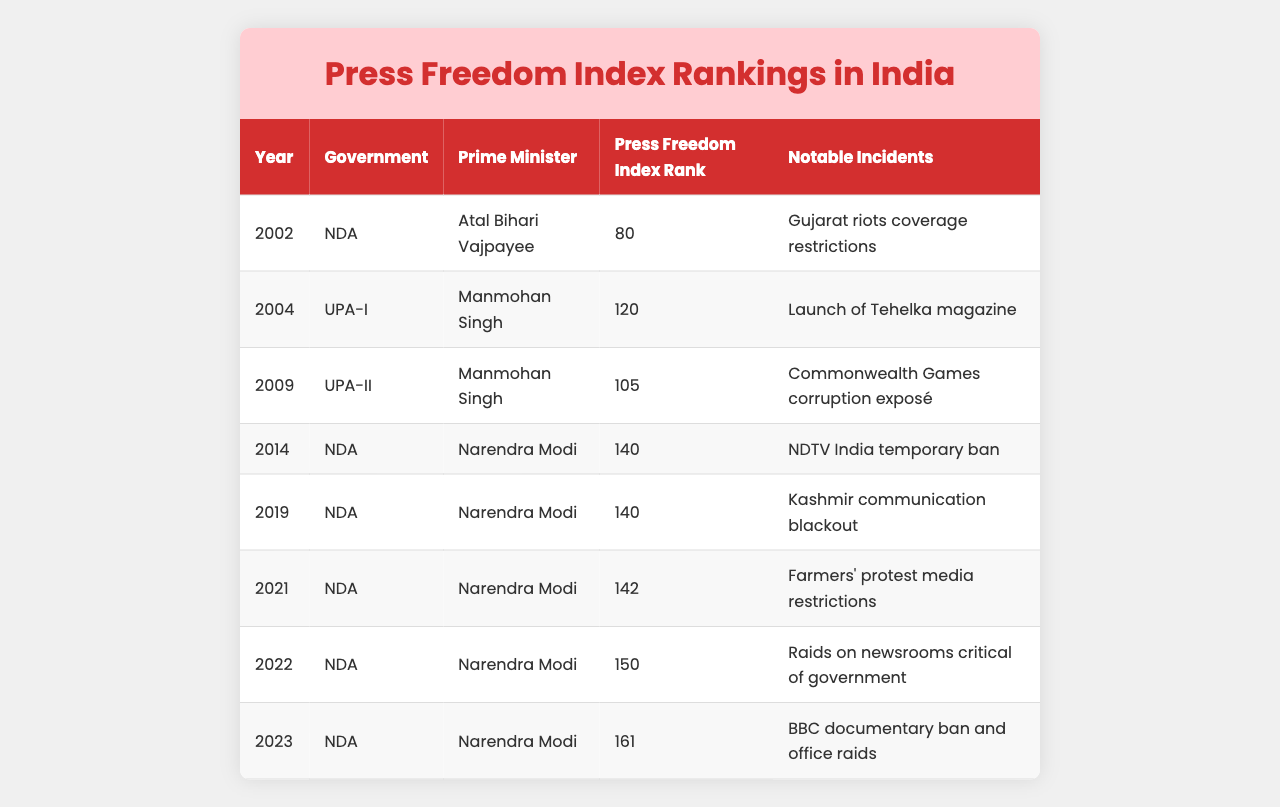What was India's Press Freedom Index rank in 2023? In the data table, the rank for the year 2023 is listed under the "Press Freedom Index Rank," which states it was 161.
Answer: 161 Which government was in power in India during the year 2019? The table indicates that the government in 2019 was NDA, and the Prime Minister was Narendra Modi.
Answer: NDA What notable incident occurred in India regarding press freedom in 2021? Referring to the "Notable Incidents" column, in 2021, the Farmers' protest media restrictions are documented as a significant incident affecting press freedom.
Answer: Farmers' protest media restrictions What was the change in India's Press Freedom Index rank from 2021 to 2022? The rank in 2021 was 142, and the rank in 2022 was 150. Thus, the change is 150 - 142 = -8, indicating a decline.
Answer: -8 Did India's Press Freedom Index rank improve from 2014 to 2019? The rank in 2014 was 140 and the rank in 2019 remained 140, indicating there was no improvement. Therefore, it's false.
Answer: No Which year saw the lowest Press Freedom Index rank for India? By reviewing the rank values in the table, 2023 has the lowest rank at 161, indicating the worst state for press freedom.
Answer: 2023 How many notable incidents were reported under the NDA government? In the table, under the NDA government, there are four notable incidents listed (2014, 2019, 2021, 2022, and 2023), therefore totaling five occurrences.
Answer: 5 From the data, what is the average Press Freedom Index rank during the UPA governments? Calculating the ranks for UPA-I (120) and UPA-II (105) gives (120 + 105) / 2 = 112.5, so the average rank during UPA governments is 112.5.
Answer: 112.5 Was the rank of India under Narendra Modi higher or lower than that under Atal Bihari Vajpayee? Modi's lowest rank in the data is 161 while Vajpayee's rank is 80, thus Modi's rank is lower, indicating a decline in press freedom.
Answer: Lower What trend can be observed in India's Press Freedom Index rankings from 2014 to 2023? Analyzing the ranks, it shows a consistent decline from 140 (2014) to 161 (2023), indicating worsening press freedom over these years.
Answer: Consistent decline 